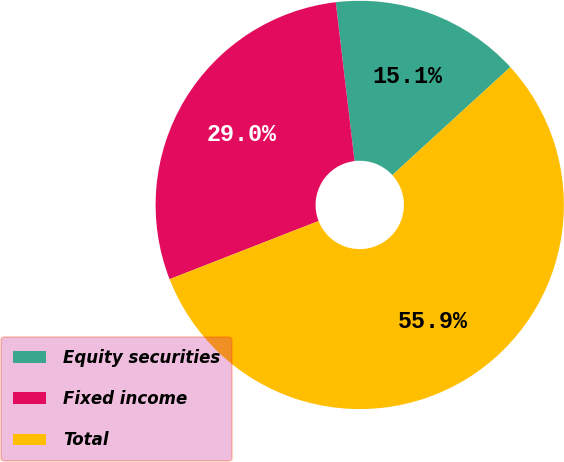<chart> <loc_0><loc_0><loc_500><loc_500><pie_chart><fcel>Equity securities<fcel>Fixed income<fcel>Total<nl><fcel>15.08%<fcel>29.05%<fcel>55.87%<nl></chart> 